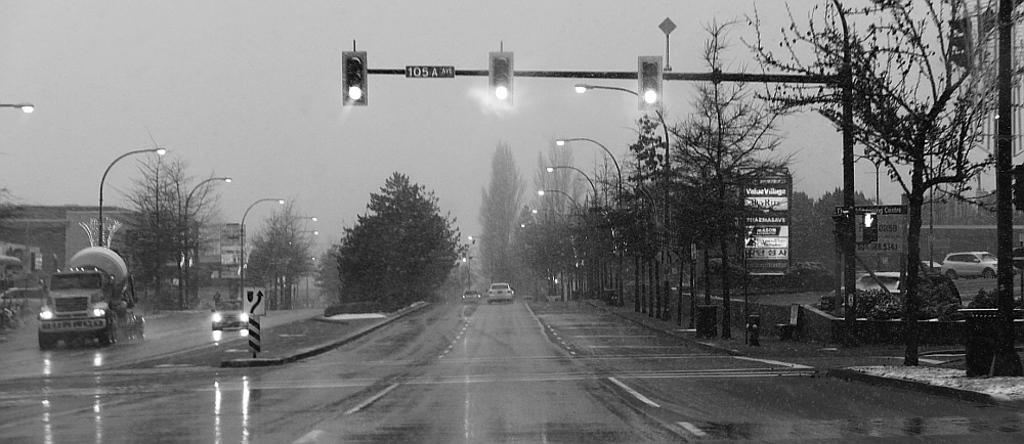Describe this image in one or two sentences. This is the road, it is raining, in the middle there are traffic signals. On either side of this there are trees. At the top it is the sky. 